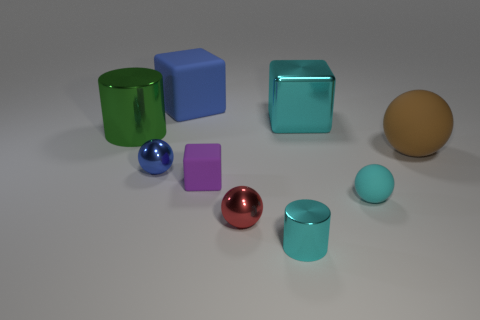Add 1 large spheres. How many objects exist? 10 Subtract all spheres. How many objects are left? 5 Subtract all rubber things. Subtract all large cyan shiny cubes. How many objects are left? 4 Add 9 large metallic blocks. How many large metallic blocks are left? 10 Add 9 green cylinders. How many green cylinders exist? 10 Subtract 0 blue cylinders. How many objects are left? 9 